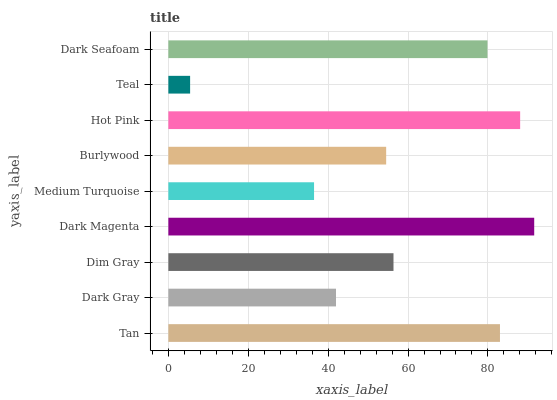Is Teal the minimum?
Answer yes or no. Yes. Is Dark Magenta the maximum?
Answer yes or no. Yes. Is Dark Gray the minimum?
Answer yes or no. No. Is Dark Gray the maximum?
Answer yes or no. No. Is Tan greater than Dark Gray?
Answer yes or no. Yes. Is Dark Gray less than Tan?
Answer yes or no. Yes. Is Dark Gray greater than Tan?
Answer yes or no. No. Is Tan less than Dark Gray?
Answer yes or no. No. Is Dim Gray the high median?
Answer yes or no. Yes. Is Dim Gray the low median?
Answer yes or no. Yes. Is Dark Magenta the high median?
Answer yes or no. No. Is Hot Pink the low median?
Answer yes or no. No. 